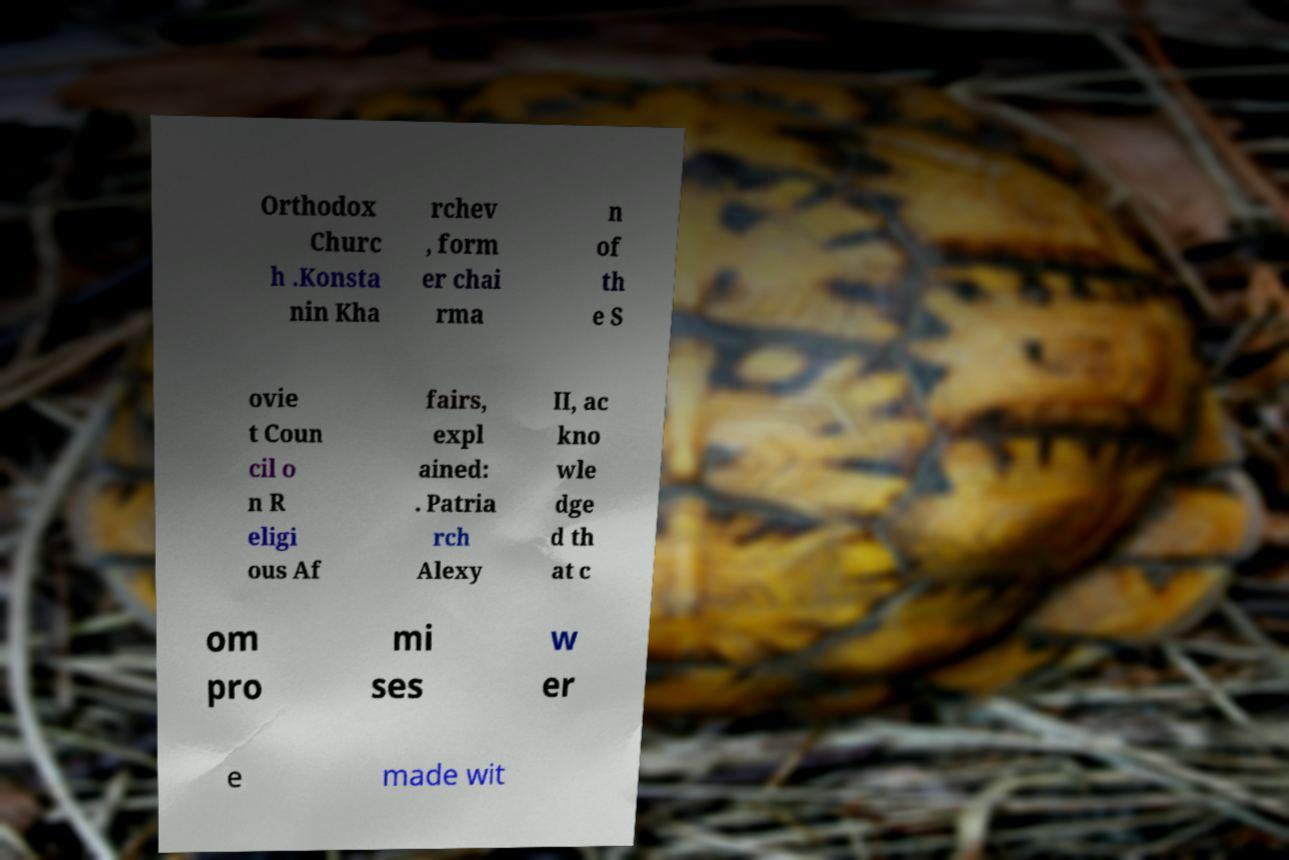Could you extract and type out the text from this image? Orthodox Churc h .Konsta nin Kha rchev , form er chai rma n of th e S ovie t Coun cil o n R eligi ous Af fairs, expl ained: . Patria rch Alexy II, ac kno wle dge d th at c om pro mi ses w er e made wit 